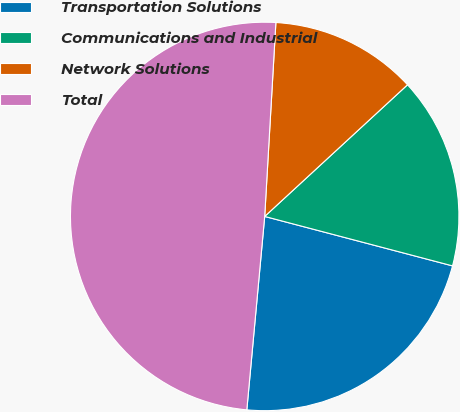<chart> <loc_0><loc_0><loc_500><loc_500><pie_chart><fcel>Transportation Solutions<fcel>Communications and Industrial<fcel>Network Solutions<fcel>Total<nl><fcel>22.37%<fcel>15.95%<fcel>12.23%<fcel>49.45%<nl></chart> 